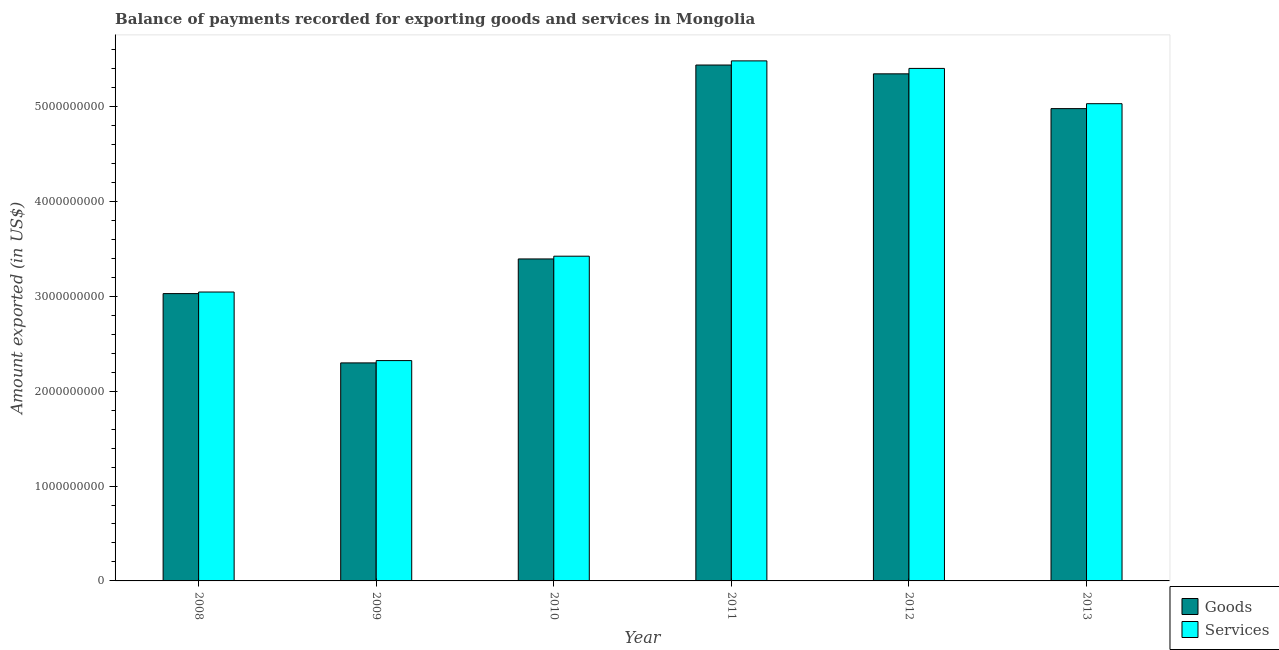How many groups of bars are there?
Your response must be concise. 6. Are the number of bars per tick equal to the number of legend labels?
Offer a very short reply. Yes. How many bars are there on the 1st tick from the left?
Provide a succinct answer. 2. How many bars are there on the 6th tick from the right?
Provide a short and direct response. 2. What is the amount of goods exported in 2013?
Provide a succinct answer. 4.98e+09. Across all years, what is the maximum amount of services exported?
Your answer should be very brief. 5.48e+09. Across all years, what is the minimum amount of goods exported?
Ensure brevity in your answer.  2.30e+09. In which year was the amount of goods exported maximum?
Provide a succinct answer. 2011. What is the total amount of services exported in the graph?
Provide a short and direct response. 2.47e+1. What is the difference between the amount of services exported in 2011 and that in 2013?
Your answer should be very brief. 4.51e+08. What is the difference between the amount of services exported in 2012 and the amount of goods exported in 2010?
Provide a succinct answer. 1.98e+09. What is the average amount of goods exported per year?
Ensure brevity in your answer.  4.08e+09. In the year 2011, what is the difference between the amount of goods exported and amount of services exported?
Give a very brief answer. 0. In how many years, is the amount of services exported greater than 1200000000 US$?
Make the answer very short. 6. What is the ratio of the amount of services exported in 2008 to that in 2010?
Provide a short and direct response. 0.89. Is the amount of goods exported in 2008 less than that in 2012?
Provide a short and direct response. Yes. Is the difference between the amount of goods exported in 2012 and 2013 greater than the difference between the amount of services exported in 2012 and 2013?
Ensure brevity in your answer.  No. What is the difference between the highest and the second highest amount of goods exported?
Your response must be concise. 9.29e+07. What is the difference between the highest and the lowest amount of goods exported?
Your answer should be compact. 3.14e+09. In how many years, is the amount of goods exported greater than the average amount of goods exported taken over all years?
Give a very brief answer. 3. Is the sum of the amount of goods exported in 2010 and 2012 greater than the maximum amount of services exported across all years?
Provide a short and direct response. Yes. What does the 1st bar from the left in 2011 represents?
Make the answer very short. Goods. What does the 2nd bar from the right in 2009 represents?
Offer a terse response. Goods. How many bars are there?
Offer a terse response. 12. Are all the bars in the graph horizontal?
Provide a short and direct response. No. How many years are there in the graph?
Your answer should be compact. 6. Does the graph contain any zero values?
Your response must be concise. No. Does the graph contain grids?
Your answer should be very brief. No. Where does the legend appear in the graph?
Keep it short and to the point. Bottom right. What is the title of the graph?
Offer a very short reply. Balance of payments recorded for exporting goods and services in Mongolia. Does "Female labourers" appear as one of the legend labels in the graph?
Provide a short and direct response. No. What is the label or title of the Y-axis?
Your answer should be very brief. Amount exported (in US$). What is the Amount exported (in US$) of Goods in 2008?
Offer a very short reply. 3.03e+09. What is the Amount exported (in US$) of Services in 2008?
Make the answer very short. 3.05e+09. What is the Amount exported (in US$) in Goods in 2009?
Provide a short and direct response. 2.30e+09. What is the Amount exported (in US$) in Services in 2009?
Make the answer very short. 2.32e+09. What is the Amount exported (in US$) of Goods in 2010?
Provide a short and direct response. 3.39e+09. What is the Amount exported (in US$) of Services in 2010?
Keep it short and to the point. 3.42e+09. What is the Amount exported (in US$) in Goods in 2011?
Provide a succinct answer. 5.44e+09. What is the Amount exported (in US$) of Services in 2011?
Make the answer very short. 5.48e+09. What is the Amount exported (in US$) of Goods in 2012?
Provide a succinct answer. 5.34e+09. What is the Amount exported (in US$) of Services in 2012?
Give a very brief answer. 5.40e+09. What is the Amount exported (in US$) in Goods in 2013?
Provide a succinct answer. 4.98e+09. What is the Amount exported (in US$) in Services in 2013?
Provide a short and direct response. 5.03e+09. Across all years, what is the maximum Amount exported (in US$) in Goods?
Your answer should be compact. 5.44e+09. Across all years, what is the maximum Amount exported (in US$) of Services?
Offer a very short reply. 5.48e+09. Across all years, what is the minimum Amount exported (in US$) of Goods?
Give a very brief answer. 2.30e+09. Across all years, what is the minimum Amount exported (in US$) in Services?
Ensure brevity in your answer.  2.32e+09. What is the total Amount exported (in US$) in Goods in the graph?
Keep it short and to the point. 2.45e+1. What is the total Amount exported (in US$) of Services in the graph?
Your answer should be compact. 2.47e+1. What is the difference between the Amount exported (in US$) in Goods in 2008 and that in 2009?
Ensure brevity in your answer.  7.30e+08. What is the difference between the Amount exported (in US$) of Services in 2008 and that in 2009?
Provide a short and direct response. 7.23e+08. What is the difference between the Amount exported (in US$) of Goods in 2008 and that in 2010?
Provide a succinct answer. -3.65e+08. What is the difference between the Amount exported (in US$) in Services in 2008 and that in 2010?
Keep it short and to the point. -3.78e+08. What is the difference between the Amount exported (in US$) of Goods in 2008 and that in 2011?
Ensure brevity in your answer.  -2.41e+09. What is the difference between the Amount exported (in US$) in Services in 2008 and that in 2011?
Offer a very short reply. -2.44e+09. What is the difference between the Amount exported (in US$) in Goods in 2008 and that in 2012?
Your answer should be compact. -2.32e+09. What is the difference between the Amount exported (in US$) of Services in 2008 and that in 2012?
Ensure brevity in your answer.  -2.36e+09. What is the difference between the Amount exported (in US$) of Goods in 2008 and that in 2013?
Offer a terse response. -1.95e+09. What is the difference between the Amount exported (in US$) in Services in 2008 and that in 2013?
Your answer should be very brief. -1.99e+09. What is the difference between the Amount exported (in US$) of Goods in 2009 and that in 2010?
Offer a terse response. -1.10e+09. What is the difference between the Amount exported (in US$) of Services in 2009 and that in 2010?
Offer a very short reply. -1.10e+09. What is the difference between the Amount exported (in US$) in Goods in 2009 and that in 2011?
Offer a terse response. -3.14e+09. What is the difference between the Amount exported (in US$) in Services in 2009 and that in 2011?
Your answer should be very brief. -3.16e+09. What is the difference between the Amount exported (in US$) in Goods in 2009 and that in 2012?
Provide a succinct answer. -3.05e+09. What is the difference between the Amount exported (in US$) of Services in 2009 and that in 2012?
Ensure brevity in your answer.  -3.08e+09. What is the difference between the Amount exported (in US$) in Goods in 2009 and that in 2013?
Your response must be concise. -2.68e+09. What is the difference between the Amount exported (in US$) of Services in 2009 and that in 2013?
Ensure brevity in your answer.  -2.71e+09. What is the difference between the Amount exported (in US$) of Goods in 2010 and that in 2011?
Make the answer very short. -2.04e+09. What is the difference between the Amount exported (in US$) in Services in 2010 and that in 2011?
Provide a succinct answer. -2.06e+09. What is the difference between the Amount exported (in US$) of Goods in 2010 and that in 2012?
Your response must be concise. -1.95e+09. What is the difference between the Amount exported (in US$) of Services in 2010 and that in 2012?
Ensure brevity in your answer.  -1.98e+09. What is the difference between the Amount exported (in US$) in Goods in 2010 and that in 2013?
Provide a succinct answer. -1.58e+09. What is the difference between the Amount exported (in US$) of Services in 2010 and that in 2013?
Your response must be concise. -1.61e+09. What is the difference between the Amount exported (in US$) of Goods in 2011 and that in 2012?
Provide a short and direct response. 9.29e+07. What is the difference between the Amount exported (in US$) in Services in 2011 and that in 2012?
Keep it short and to the point. 7.94e+07. What is the difference between the Amount exported (in US$) in Goods in 2011 and that in 2013?
Ensure brevity in your answer.  4.59e+08. What is the difference between the Amount exported (in US$) of Services in 2011 and that in 2013?
Your response must be concise. 4.51e+08. What is the difference between the Amount exported (in US$) in Goods in 2012 and that in 2013?
Provide a succinct answer. 3.67e+08. What is the difference between the Amount exported (in US$) in Services in 2012 and that in 2013?
Ensure brevity in your answer.  3.72e+08. What is the difference between the Amount exported (in US$) in Goods in 2008 and the Amount exported (in US$) in Services in 2009?
Offer a terse response. 7.06e+08. What is the difference between the Amount exported (in US$) in Goods in 2008 and the Amount exported (in US$) in Services in 2010?
Offer a terse response. -3.94e+08. What is the difference between the Amount exported (in US$) in Goods in 2008 and the Amount exported (in US$) in Services in 2011?
Provide a short and direct response. -2.45e+09. What is the difference between the Amount exported (in US$) in Goods in 2008 and the Amount exported (in US$) in Services in 2012?
Make the answer very short. -2.37e+09. What is the difference between the Amount exported (in US$) in Goods in 2008 and the Amount exported (in US$) in Services in 2013?
Give a very brief answer. -2.00e+09. What is the difference between the Amount exported (in US$) in Goods in 2009 and the Amount exported (in US$) in Services in 2010?
Your answer should be compact. -1.12e+09. What is the difference between the Amount exported (in US$) in Goods in 2009 and the Amount exported (in US$) in Services in 2011?
Ensure brevity in your answer.  -3.18e+09. What is the difference between the Amount exported (in US$) in Goods in 2009 and the Amount exported (in US$) in Services in 2012?
Ensure brevity in your answer.  -3.10e+09. What is the difference between the Amount exported (in US$) in Goods in 2009 and the Amount exported (in US$) in Services in 2013?
Make the answer very short. -2.73e+09. What is the difference between the Amount exported (in US$) of Goods in 2010 and the Amount exported (in US$) of Services in 2011?
Provide a short and direct response. -2.09e+09. What is the difference between the Amount exported (in US$) in Goods in 2010 and the Amount exported (in US$) in Services in 2012?
Give a very brief answer. -2.01e+09. What is the difference between the Amount exported (in US$) in Goods in 2010 and the Amount exported (in US$) in Services in 2013?
Your response must be concise. -1.64e+09. What is the difference between the Amount exported (in US$) of Goods in 2011 and the Amount exported (in US$) of Services in 2012?
Ensure brevity in your answer.  3.57e+07. What is the difference between the Amount exported (in US$) in Goods in 2011 and the Amount exported (in US$) in Services in 2013?
Offer a terse response. 4.08e+08. What is the difference between the Amount exported (in US$) in Goods in 2012 and the Amount exported (in US$) in Services in 2013?
Ensure brevity in your answer.  3.15e+08. What is the average Amount exported (in US$) in Goods per year?
Your answer should be compact. 4.08e+09. What is the average Amount exported (in US$) in Services per year?
Your answer should be compact. 4.12e+09. In the year 2008, what is the difference between the Amount exported (in US$) of Goods and Amount exported (in US$) of Services?
Make the answer very short. -1.65e+07. In the year 2009, what is the difference between the Amount exported (in US$) in Goods and Amount exported (in US$) in Services?
Offer a terse response. -2.43e+07. In the year 2010, what is the difference between the Amount exported (in US$) of Goods and Amount exported (in US$) of Services?
Your answer should be compact. -2.89e+07. In the year 2011, what is the difference between the Amount exported (in US$) in Goods and Amount exported (in US$) in Services?
Your response must be concise. -4.37e+07. In the year 2012, what is the difference between the Amount exported (in US$) of Goods and Amount exported (in US$) of Services?
Give a very brief answer. -5.72e+07. In the year 2013, what is the difference between the Amount exported (in US$) in Goods and Amount exported (in US$) in Services?
Give a very brief answer. -5.19e+07. What is the ratio of the Amount exported (in US$) of Goods in 2008 to that in 2009?
Your answer should be compact. 1.32. What is the ratio of the Amount exported (in US$) in Services in 2008 to that in 2009?
Provide a short and direct response. 1.31. What is the ratio of the Amount exported (in US$) of Goods in 2008 to that in 2010?
Your answer should be very brief. 0.89. What is the ratio of the Amount exported (in US$) of Services in 2008 to that in 2010?
Provide a succinct answer. 0.89. What is the ratio of the Amount exported (in US$) in Goods in 2008 to that in 2011?
Your answer should be compact. 0.56. What is the ratio of the Amount exported (in US$) of Services in 2008 to that in 2011?
Make the answer very short. 0.56. What is the ratio of the Amount exported (in US$) of Goods in 2008 to that in 2012?
Your answer should be very brief. 0.57. What is the ratio of the Amount exported (in US$) of Services in 2008 to that in 2012?
Your answer should be very brief. 0.56. What is the ratio of the Amount exported (in US$) in Goods in 2008 to that in 2013?
Provide a short and direct response. 0.61. What is the ratio of the Amount exported (in US$) of Services in 2008 to that in 2013?
Keep it short and to the point. 0.61. What is the ratio of the Amount exported (in US$) in Goods in 2009 to that in 2010?
Offer a very short reply. 0.68. What is the ratio of the Amount exported (in US$) of Services in 2009 to that in 2010?
Your answer should be very brief. 0.68. What is the ratio of the Amount exported (in US$) of Goods in 2009 to that in 2011?
Your response must be concise. 0.42. What is the ratio of the Amount exported (in US$) of Services in 2009 to that in 2011?
Make the answer very short. 0.42. What is the ratio of the Amount exported (in US$) in Goods in 2009 to that in 2012?
Keep it short and to the point. 0.43. What is the ratio of the Amount exported (in US$) of Services in 2009 to that in 2012?
Your response must be concise. 0.43. What is the ratio of the Amount exported (in US$) in Goods in 2009 to that in 2013?
Offer a terse response. 0.46. What is the ratio of the Amount exported (in US$) of Services in 2009 to that in 2013?
Offer a very short reply. 0.46. What is the ratio of the Amount exported (in US$) in Goods in 2010 to that in 2011?
Provide a succinct answer. 0.62. What is the ratio of the Amount exported (in US$) in Services in 2010 to that in 2011?
Offer a very short reply. 0.62. What is the ratio of the Amount exported (in US$) in Goods in 2010 to that in 2012?
Your answer should be very brief. 0.64. What is the ratio of the Amount exported (in US$) in Services in 2010 to that in 2012?
Make the answer very short. 0.63. What is the ratio of the Amount exported (in US$) in Goods in 2010 to that in 2013?
Provide a short and direct response. 0.68. What is the ratio of the Amount exported (in US$) in Services in 2010 to that in 2013?
Provide a succinct answer. 0.68. What is the ratio of the Amount exported (in US$) in Goods in 2011 to that in 2012?
Keep it short and to the point. 1.02. What is the ratio of the Amount exported (in US$) in Services in 2011 to that in 2012?
Your response must be concise. 1.01. What is the ratio of the Amount exported (in US$) of Goods in 2011 to that in 2013?
Give a very brief answer. 1.09. What is the ratio of the Amount exported (in US$) of Services in 2011 to that in 2013?
Provide a succinct answer. 1.09. What is the ratio of the Amount exported (in US$) of Goods in 2012 to that in 2013?
Your answer should be very brief. 1.07. What is the ratio of the Amount exported (in US$) in Services in 2012 to that in 2013?
Your response must be concise. 1.07. What is the difference between the highest and the second highest Amount exported (in US$) of Goods?
Make the answer very short. 9.29e+07. What is the difference between the highest and the second highest Amount exported (in US$) of Services?
Your response must be concise. 7.94e+07. What is the difference between the highest and the lowest Amount exported (in US$) of Goods?
Your answer should be compact. 3.14e+09. What is the difference between the highest and the lowest Amount exported (in US$) of Services?
Offer a terse response. 3.16e+09. 